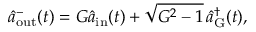Convert formula to latex. <formula><loc_0><loc_0><loc_500><loc_500>\hat { a } _ { o u t } ^ { - } ( t ) = G \hat { a } _ { i n } ( t ) + \sqrt { G ^ { 2 } - 1 } \, \hat { a } _ { G } ^ { \dagger } ( t ) ,</formula> 